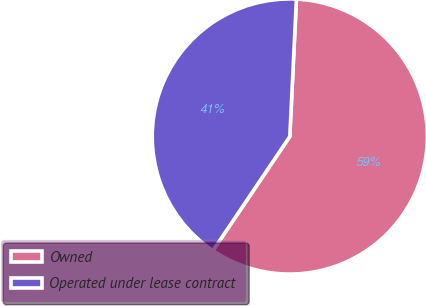Convert chart to OTSL. <chart><loc_0><loc_0><loc_500><loc_500><pie_chart><fcel>Owned<fcel>Operated under lease contract<nl><fcel>58.67%<fcel>41.33%<nl></chart> 